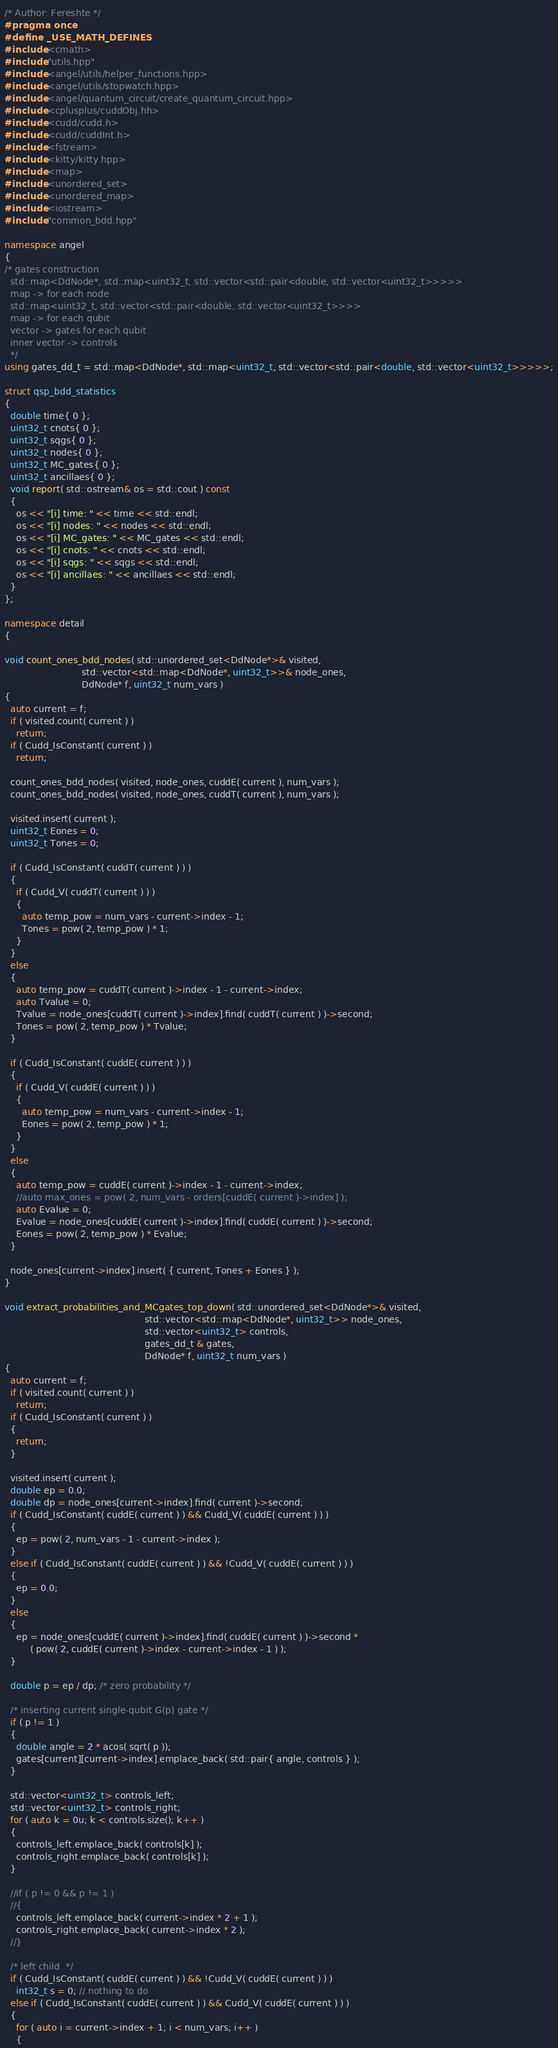<code> <loc_0><loc_0><loc_500><loc_500><_C++_>/* Author: Fereshte */
#pragma once
#define _USE_MATH_DEFINES
#include <cmath> 
#include "utils.hpp"
#include <angel/utils/helper_functions.hpp>
#include <angel/utils/stopwatch.hpp>
#include <angel/quantum_circuit/create_quantum_circuit.hpp>
#include <cplusplus/cuddObj.hh>
#include <cudd/cudd.h>
#include <cudd/cuddInt.h>
#include <fstream>
#include <kitty/kitty.hpp>
#include <map>
#include <unordered_set>
#include <unordered_map>
#include <iostream>
#include "common_bdd.hpp"

namespace angel
{
/* gates construction
  std::map<DdNode*, std::map<uint32_t, std::vector<std::pair<double, std::vector<uint32_t>>>>>
  map -> for each node
  std::map<uint32_t, std::vector<std::pair<double, std::vector<uint32_t>>>>
  map -> for each qubit
  vector -> gates for each qubit
  inner vector -> controls
  */
using gates_dd_t = std::map<DdNode*, std::map<uint32_t, std::vector<std::pair<double, std::vector<uint32_t>>>>>;

struct qsp_bdd_statistics
{
  double time{ 0 };
  uint32_t cnots{ 0 };
  uint32_t sqgs{ 0 };
  uint32_t nodes{ 0 };
  uint32_t MC_gates{ 0 };
  uint32_t ancillaes{ 0 };
  void report( std::ostream& os = std::cout ) const
  {
    os << "[i] time: " << time << std::endl;
    os << "[i] nodes: " << nodes << std::endl;
    os << "[i] MC_gates: " << MC_gates << std::endl;
    os << "[i] cnots: " << cnots << std::endl;
    os << "[i] sqgs: " << sqgs << std::endl;
    os << "[i] ancillaes: " << ancillaes << std::endl;
  }
};

namespace detail
{

void count_ones_bdd_nodes( std::unordered_set<DdNode*>& visited,
                           std::vector<std::map<DdNode*, uint32_t>>& node_ones,
                           DdNode* f, uint32_t num_vars )
{
  auto current = f;
  if ( visited.count( current ) )
    return;
  if ( Cudd_IsConstant( current ) )
    return;

  count_ones_bdd_nodes( visited, node_ones, cuddE( current ), num_vars );
  count_ones_bdd_nodes( visited, node_ones, cuddT( current ), num_vars );

  visited.insert( current );
  uint32_t Eones = 0;
  uint32_t Tones = 0;

  if ( Cudd_IsConstant( cuddT( current ) ) )
  {
    if ( Cudd_V( cuddT( current ) ) )
    {
      auto temp_pow = num_vars - current->index - 1;
      Tones = pow( 2, temp_pow ) * 1;
    }
  }
  else
  {
    auto temp_pow = cuddT( current )->index - 1 - current->index;
    auto Tvalue = 0;
    Tvalue = node_ones[cuddT( current )->index].find( cuddT( current ) )->second;
    Tones = pow( 2, temp_pow ) * Tvalue;
  }

  if ( Cudd_IsConstant( cuddE( current ) ) )
  {
    if ( Cudd_V( cuddE( current ) ) )
    {
      auto temp_pow = num_vars - current->index - 1;
      Eones = pow( 2, temp_pow ) * 1;
    }
  }
  else
  {
    auto temp_pow = cuddE( current )->index - 1 - current->index;
    //auto max_ones = pow( 2, num_vars - orders[cuddE( current )->index] );
    auto Evalue = 0;
    Evalue = node_ones[cuddE( current )->index].find( cuddE( current ) )->second;
    Eones = pow( 2, temp_pow ) * Evalue;
  }

  node_ones[current->index].insert( { current, Tones + Eones } );
}

void extract_probabilities_and_MCgates_top_down( std::unordered_set<DdNode*>& visited,
                                                 std::vector<std::map<DdNode*, uint32_t>> node_ones,
                                                 std::vector<uint32_t> controls,
                                                 gates_dd_t & gates,
                                                 DdNode* f, uint32_t num_vars )
{
  auto current = f;
  if ( visited.count( current ) )
    return;
  if ( Cudd_IsConstant( current ) )
  {
    return;
  }

  visited.insert( current );
  double ep = 0.0;
  double dp = node_ones[current->index].find( current )->second;
  if ( Cudd_IsConstant( cuddE( current ) ) && Cudd_V( cuddE( current ) ) )
  {
    ep = pow( 2, num_vars - 1 - current->index );
  }
  else if ( Cudd_IsConstant( cuddE( current ) ) && !Cudd_V( cuddE( current ) ) )
  {
    ep = 0.0;
  }
  else
  {
    ep = node_ones[cuddE( current )->index].find( cuddE( current ) )->second *
         ( pow( 2, cuddE( current )->index - current->index - 1 ) );
  }

  double p = ep / dp; /* zero probability */

  /* inserting current single-qubit G(p) gate */
  if ( p != 1 )
  {
    double angle = 2 * acos( sqrt( p ));
    gates[current][current->index].emplace_back( std::pair{ angle, controls } );
  }

  std::vector<uint32_t> controls_left;
  std::vector<uint32_t> controls_right;
  for ( auto k = 0u; k < controls.size(); k++ )
  {
    controls_left.emplace_back( controls[k] );
    controls_right.emplace_back( controls[k] );
  }
   
  //if ( p != 0 && p != 1 )
  //{
    controls_left.emplace_back( current->index * 2 + 1 );
    controls_right.emplace_back( current->index * 2 );
  //}

  /* left child  */
  if ( Cudd_IsConstant( cuddE( current ) ) && !Cudd_V( cuddE( current ) ) )
    int32_t s = 0; // nothing to do
  else if ( Cudd_IsConstant( cuddE( current ) ) && Cudd_V( cuddE( current ) ) )
  {
    for ( auto i = current->index + 1; i < num_vars; i++ )
    {</code> 